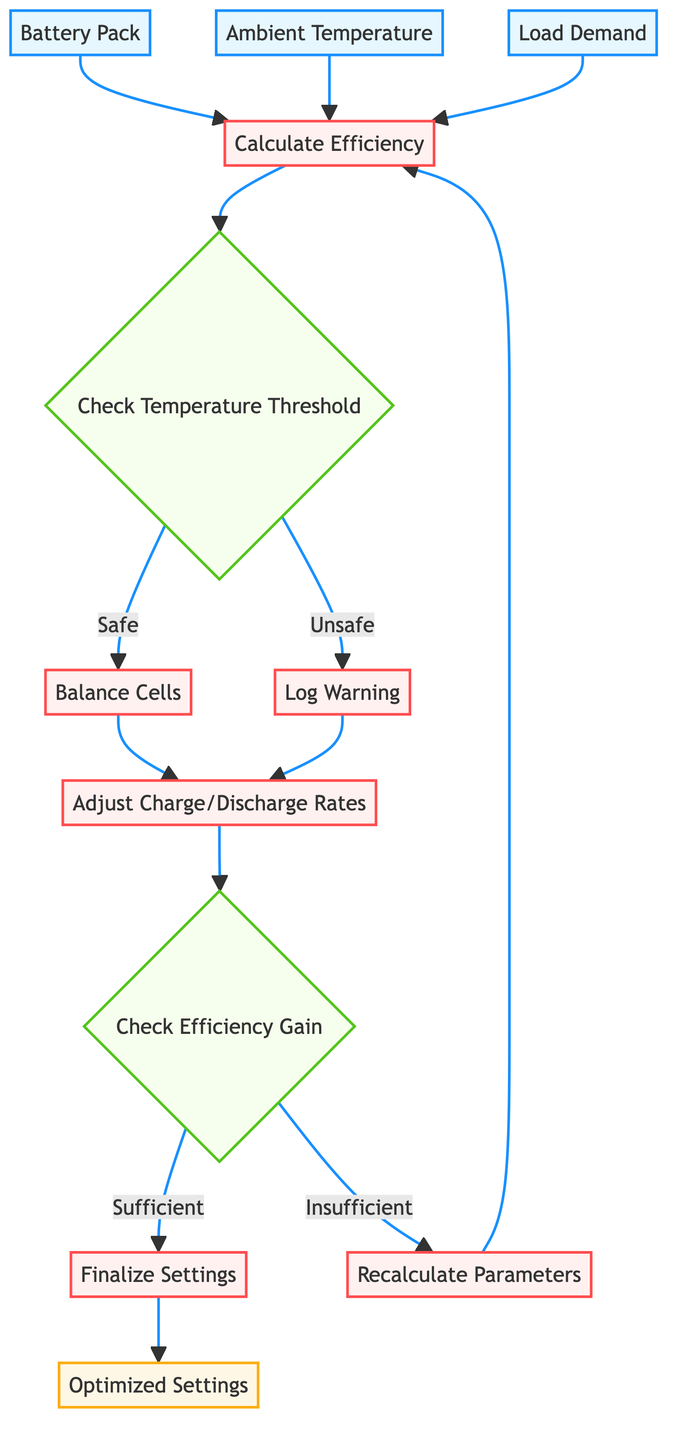What are the input parameters for the function? The function takes three parameters: battery_pack, ambient_temperature, and load_demand as inputs. These are represented in the input nodes at the start of the flowchart.
Answer: battery_pack, ambient_temperature, load_demand Which operation follows the decision node for checking the temperature threshold? After the temperature threshold is checked, if it is safe, the next step is to perform cell balancing; this is indicated by the path labeled 'Safe' leading to the Balance Cells operation.
Answer: Balance Cells What is logged if a cell temperature exceeds safe limits? If any cell temperature exceeds the predefined thresholds, a warning is logged and cooling or protective measures are triggered. This process is indicated in the flowchart as the Log Warning operation.
Answer: Log Warning How many operations are there in the diagram? The flowchart has six operations: Calculate Efficiency, Balance Cells, Log Warning, Adjust Charge/Discharge Rates, Finalize Settings, and Recalculate Parameters. Counting each distinct operation leads to the total.
Answer: 6 What is the output of the function? The final output of the optimized BMS settings is provided at the end of the flowchart, represented in the output node labeled Optimized Settings.
Answer: Optimized Settings What happens if adjustments do not improve efficiency? If the efficiency gains from the adjustments are found to be insufficient after evaluation, the flowchart indicates that parameters will be recalculated; this is shown by the path labeled 'Insufficient' leading to the Recalculate Parameters operation.
Answer: Recalculate Parameters What type of flowchart is depicted? This is a flowchart illustrating the Python function that optimizes a Battery Management System's efficiency through various input evaluations and operational processes. It clearly represents decision points and sequential operations.
Answer: Flowchart of a Python Function What is checked after adjusting charge/discharge rates? After adjusting the charge/discharge rates, the next decision made is to check if the changes lead to an improvement in overall efficiency, indicated by the decision node Check Efficiency Gain.
Answer: Check Efficiency Gain How many decision nodes are in the flowchart? The flowchart contains two decision nodes: Check Temperature Threshold and Check Efficiency Gain. Each of these nodes assesses a particular condition that affects the flow of operations.
Answer: 2 